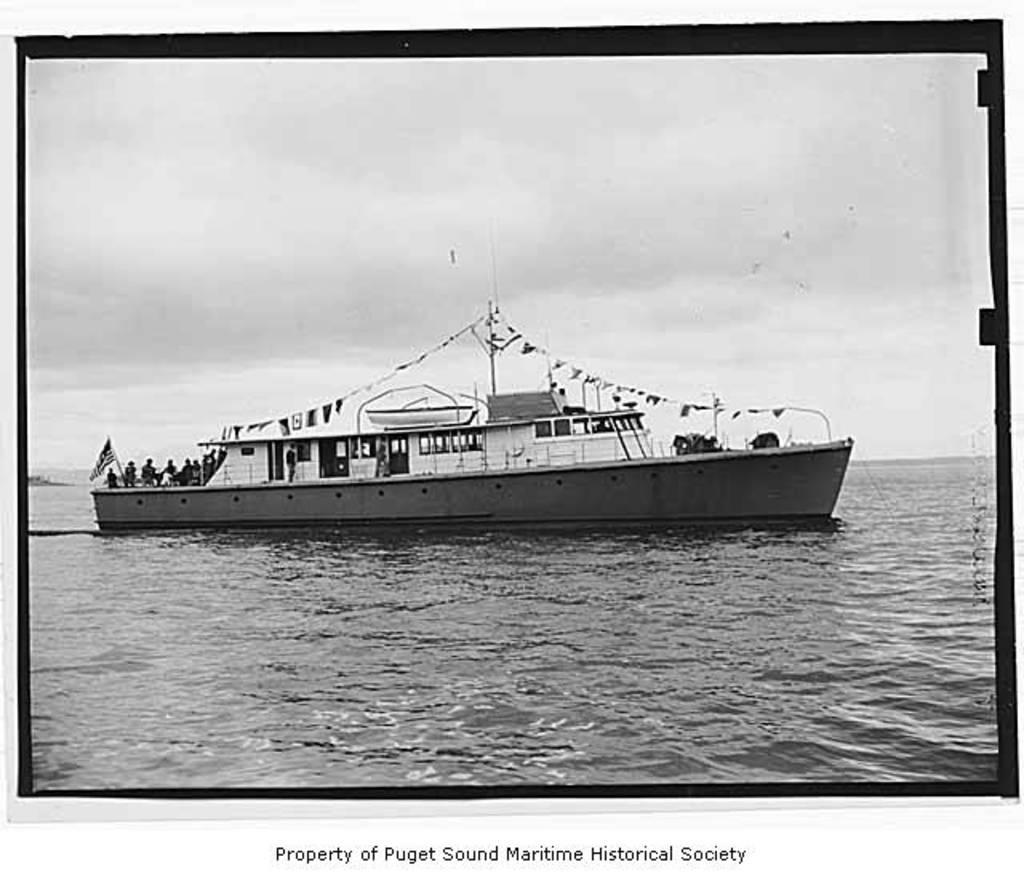<image>
Create a compact narrative representing the image presented. A black and white photo of a ship marked Property of Puget Sound Maritime Historical Society, 